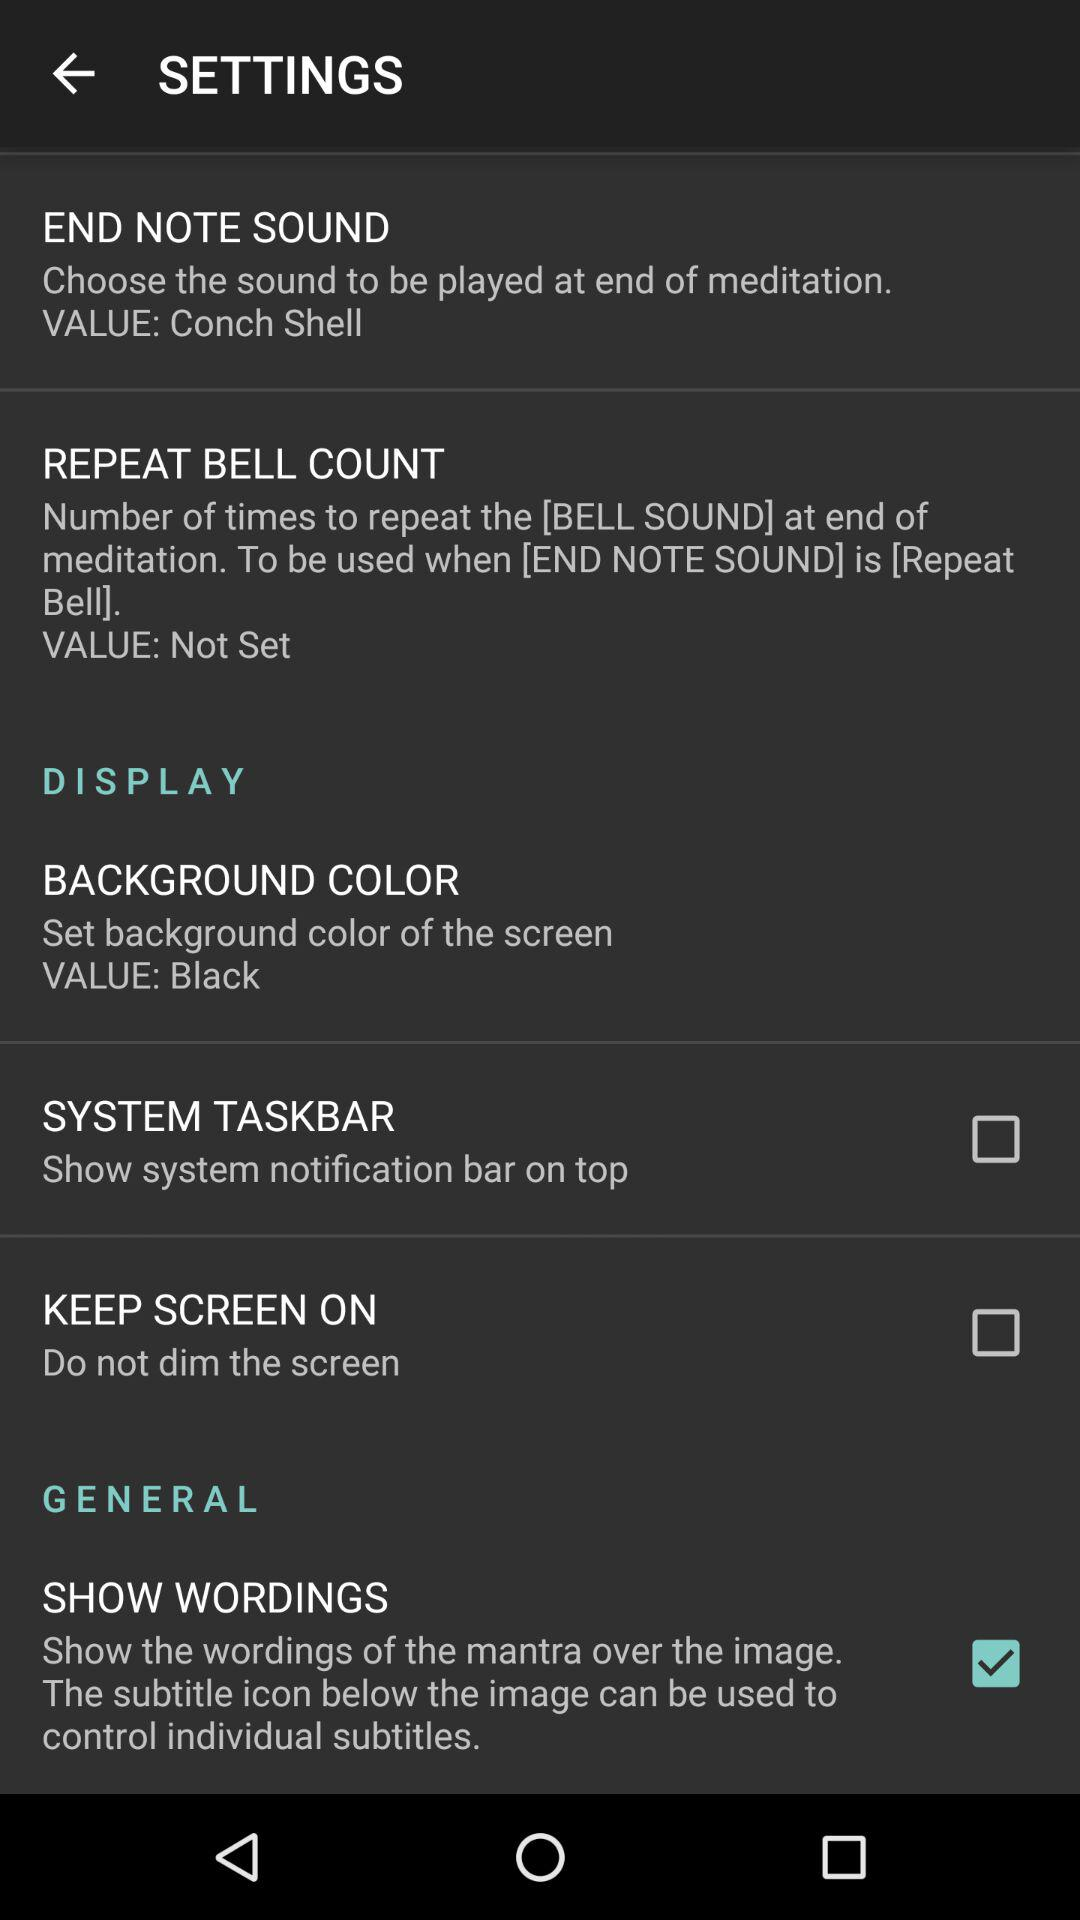What is the status of "KEEP SCREEN ON"? The status of "KEEP SCREEN ON" is "off". 